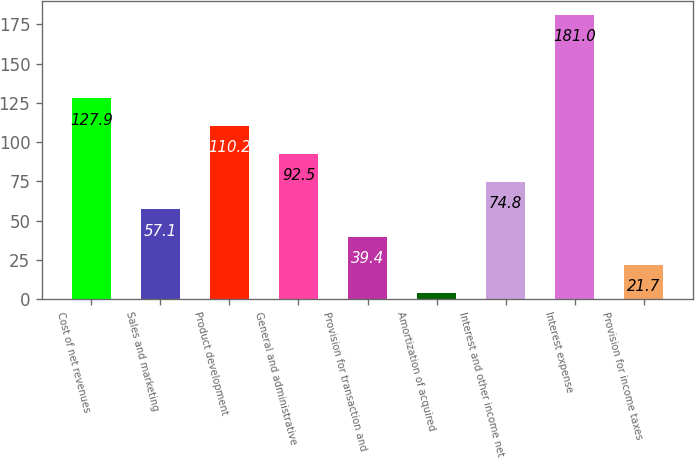Convert chart. <chart><loc_0><loc_0><loc_500><loc_500><bar_chart><fcel>Cost of net revenues<fcel>Sales and marketing<fcel>Product development<fcel>General and administrative<fcel>Provision for transaction and<fcel>Amortization of acquired<fcel>Interest and other income net<fcel>Interest expense<fcel>Provision for income taxes<nl><fcel>127.9<fcel>57.1<fcel>110.2<fcel>92.5<fcel>39.4<fcel>4<fcel>74.8<fcel>181<fcel>21.7<nl></chart> 